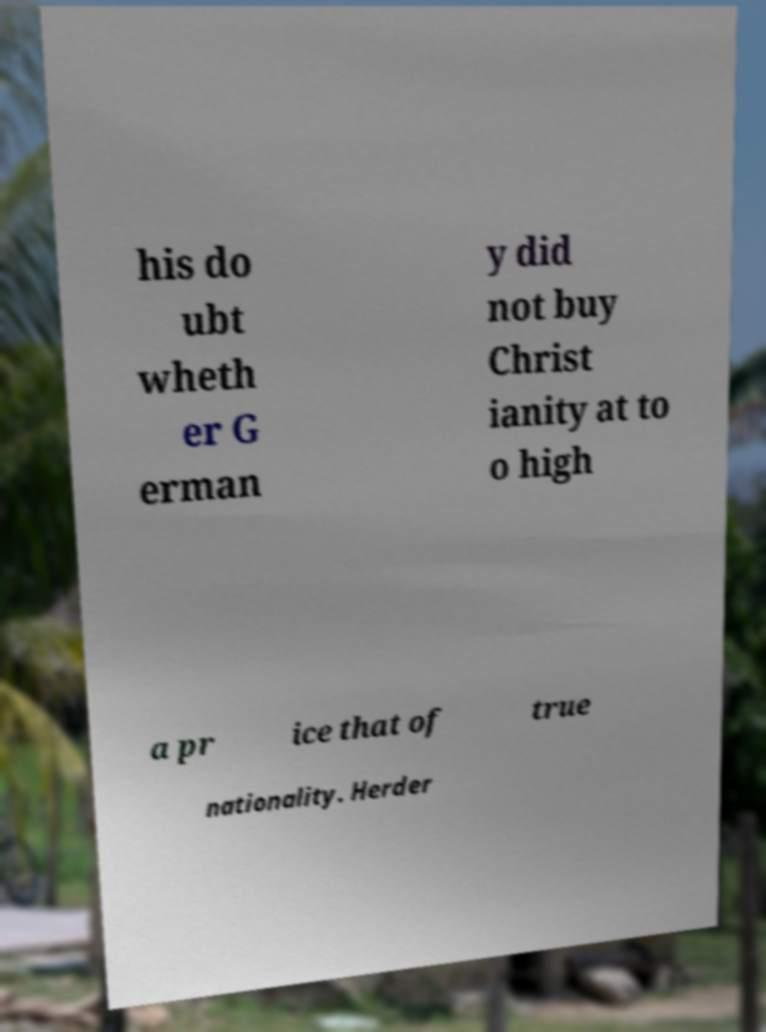Could you assist in decoding the text presented in this image and type it out clearly? his do ubt wheth er G erman y did not buy Christ ianity at to o high a pr ice that of true nationality. Herder 